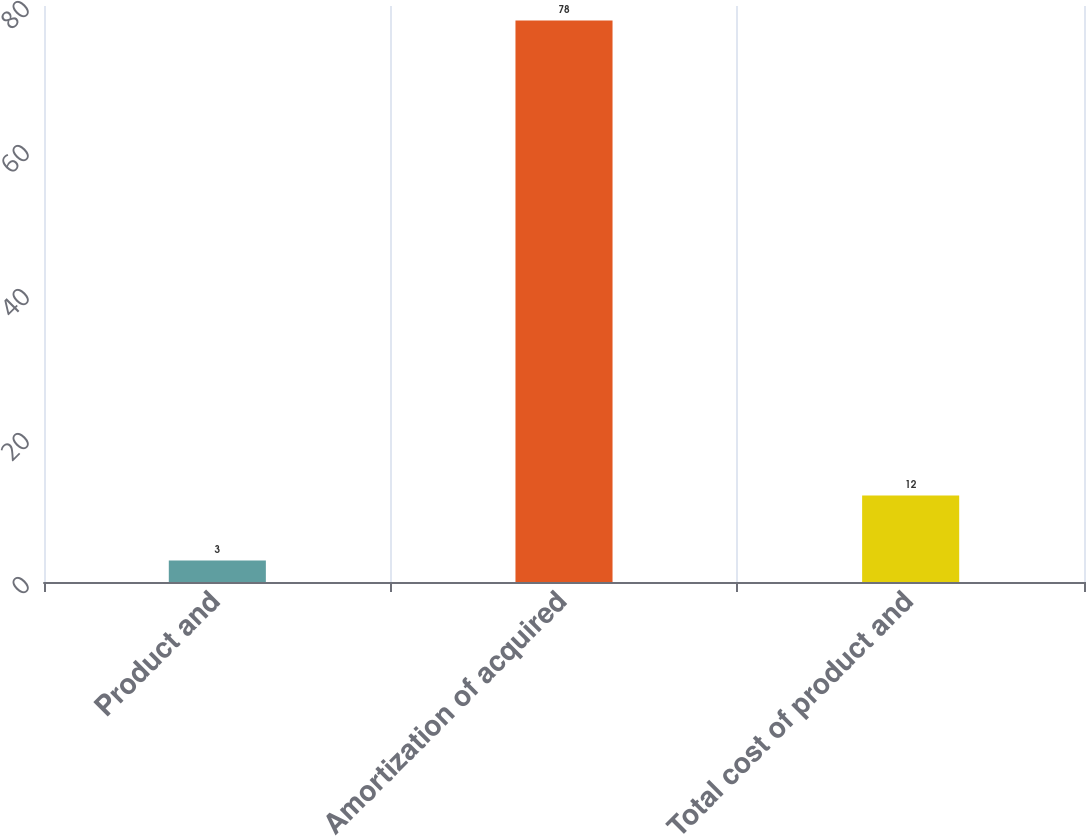<chart> <loc_0><loc_0><loc_500><loc_500><bar_chart><fcel>Product and<fcel>Amortization of acquired<fcel>Total cost of product and<nl><fcel>3<fcel>78<fcel>12<nl></chart> 